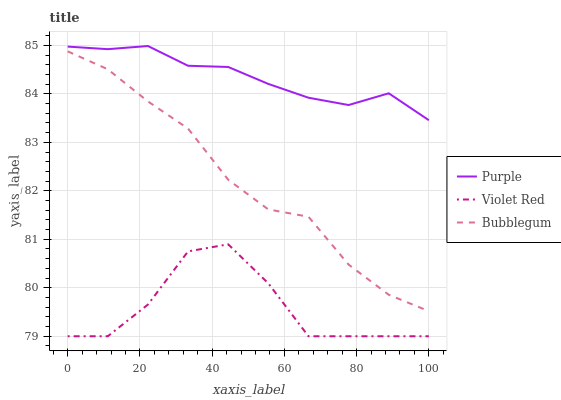Does Bubblegum have the minimum area under the curve?
Answer yes or no. No. Does Bubblegum have the maximum area under the curve?
Answer yes or no. No. Is Bubblegum the smoothest?
Answer yes or no. No. Is Bubblegum the roughest?
Answer yes or no. No. Does Bubblegum have the lowest value?
Answer yes or no. No. Does Bubblegum have the highest value?
Answer yes or no. No. Is Violet Red less than Bubblegum?
Answer yes or no. Yes. Is Purple greater than Bubblegum?
Answer yes or no. Yes. Does Violet Red intersect Bubblegum?
Answer yes or no. No. 